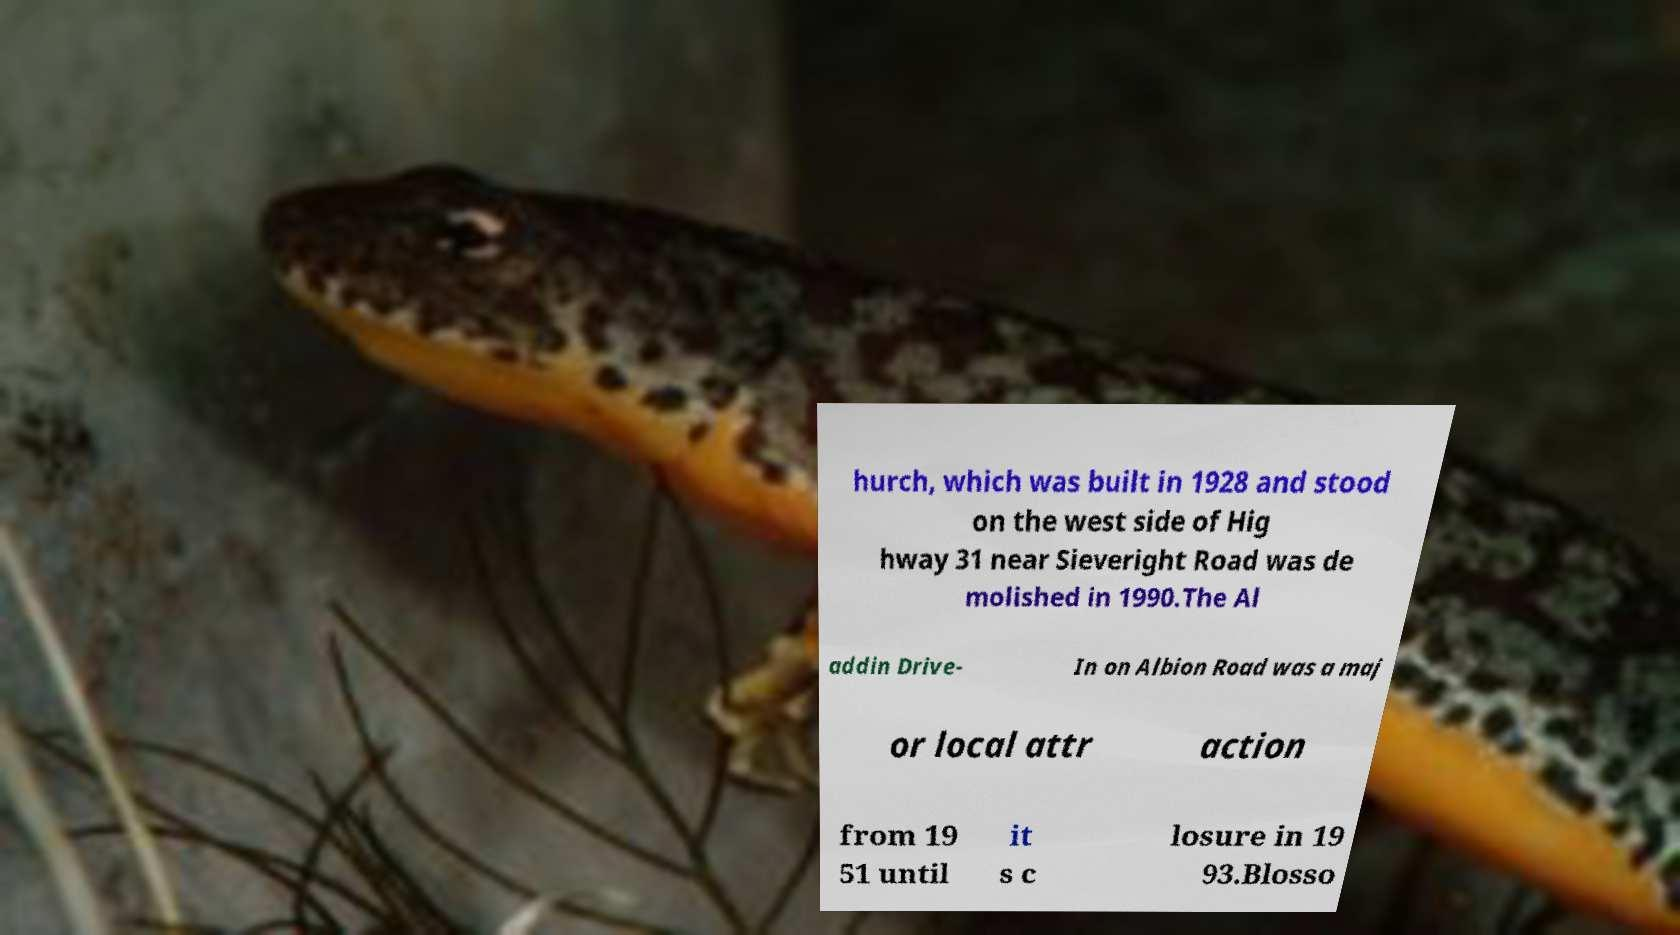For documentation purposes, I need the text within this image transcribed. Could you provide that? hurch, which was built in 1928 and stood on the west side of Hig hway 31 near Sieveright Road was de molished in 1990.The Al addin Drive- In on Albion Road was a maj or local attr action from 19 51 until it s c losure in 19 93.Blosso 